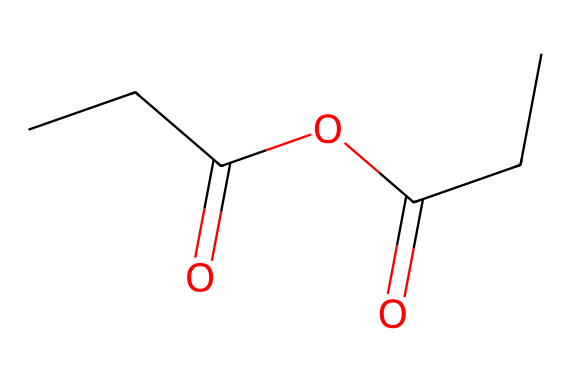What is the chemical name of this compound? By analyzing the SMILES representation, it consists of two propionic acid units joined together by an oxygen atom, indicating that it is propionic anhydride.
Answer: propionic anhydride How many carbon atoms are present in the molecule? The molecular formula derived from the SMILES shows there are 5 carbon atoms (from CCC in propionic acid), totaling to two propionic acid units.
Answer: 5 What is the total number of oxygen atoms in the molecule? From the SMILES representation, we can see that there are two carbonyl groups (C=O) and one ether group (C-O), totaling three oxygen atoms.
Answer: 3 How many double bonds are present in this molecule? There are two carbonyl groups (C=O) which represent double bonds present in the structure, and there are no other double bonds evident in the molecule.
Answer: 2 What type of functional groups are present in propionic anhydride? The molecule contains both ester (C-O) and carbonyl (C=O) functional groups, which are characteristic of acid anhydrides.
Answer: ester and carbonyl Is propionic anhydride soluble in water? Anhydrides of carboxylic acids are generally not very soluble due to their hydrophobic interactions, indicating lower solubility in water compared to more polar substances.
Answer: no 